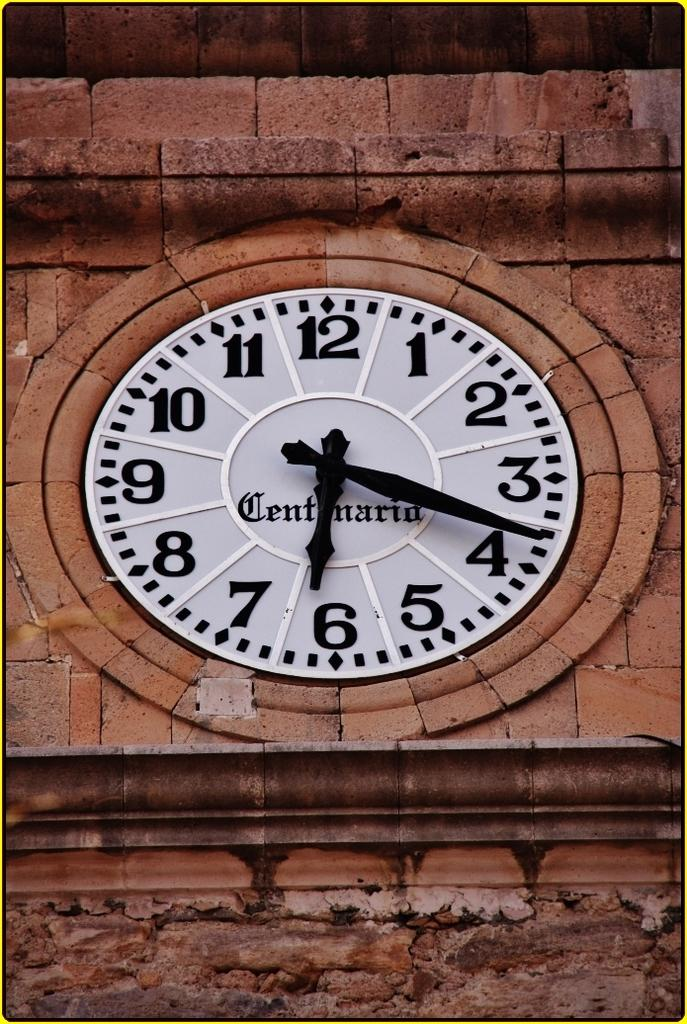<image>
Share a concise interpretation of the image provided. A clock is built into a brick building and it says Centanario. 